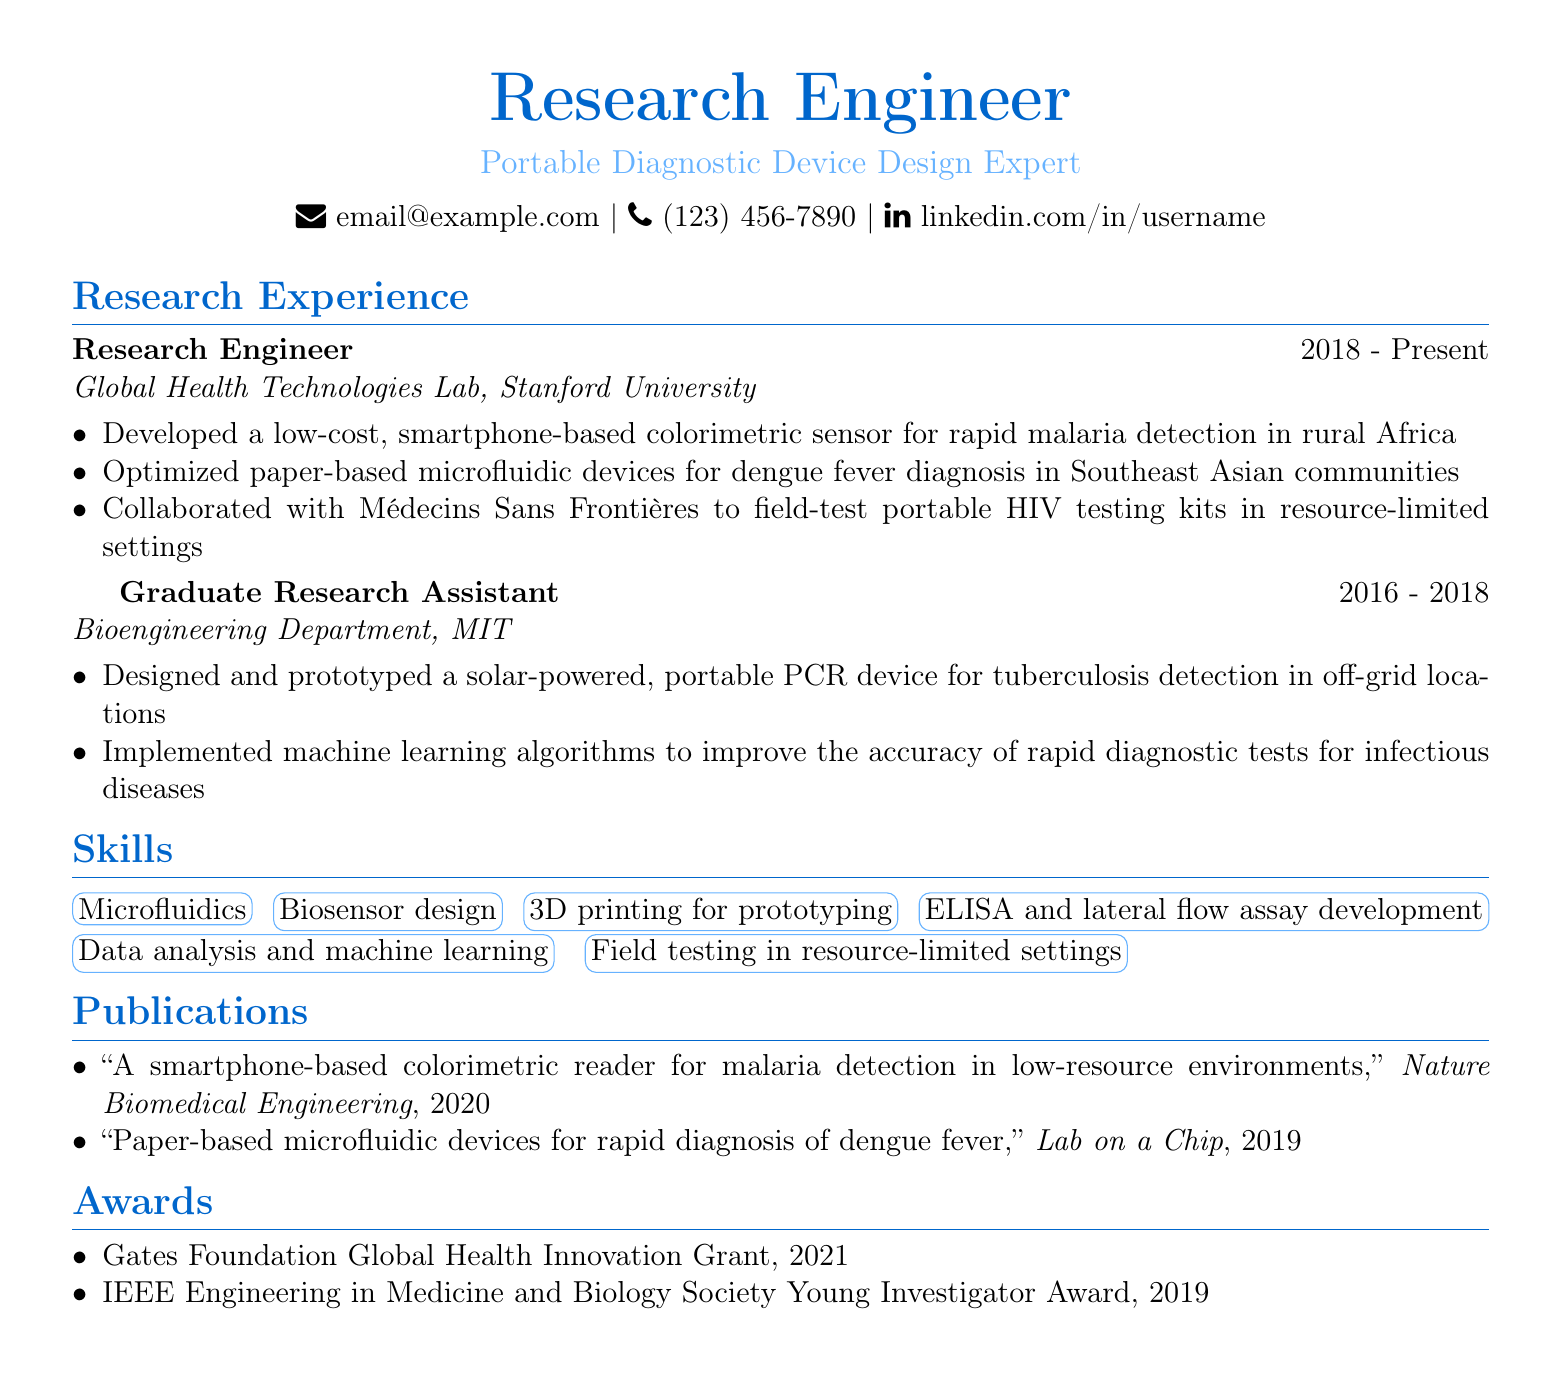What is the position held at Stanford University? The document states the position held is "Research Engineer" from 2018 to Present at Stanford University.
Answer: Research Engineer What is one of the projects completed in 2018-2023? The document lists several projects, one of which is the smartphone-based colorimetric sensor for rapid malaria detection.
Answer: Smartphone-based colorimetric sensor for rapid malaria detection Which institution was the Graduate Research Assistant associated with? The document specifies that the Graduate Research Assistant worked at the Bioengineering Department, MIT.
Answer: Bioengineering Department, MIT What award was received in 2021? The document indicates that the Gates Foundation Global Health Innovation Grant was awarded in 2021.
Answer: Gates Foundation Global Health Innovation Grant How many years of experience does the individual have in research? The individual has research experience from 2016 to Present, which totals to approximately seven years.
Answer: Approximately seven years What disease detection method was developed in the projects from 2016 to 2018? The Graduate Research Assistant's work involved developing a tuberculosis detection method using a portable PCR device.
Answer: Portable PCR device for tuberculosis detection Which publication addresses malaria detection? The publication titled "A smartphone-based colorimetric reader for malaria detection in low-resource environments" addresses malaria detection.
Answer: A smartphone-based colorimetric reader for malaria detection in low-resource environments What type of testing was field-tested with Médecins Sans Frontières? The document mentions field-testing of portable HIV testing kits.
Answer: Portable HIV testing kits What skills are highlighted in the resume? The resume lists various skills, including microfluidics and biosensor design among others.
Answer: Microfluidics, biosensor design 